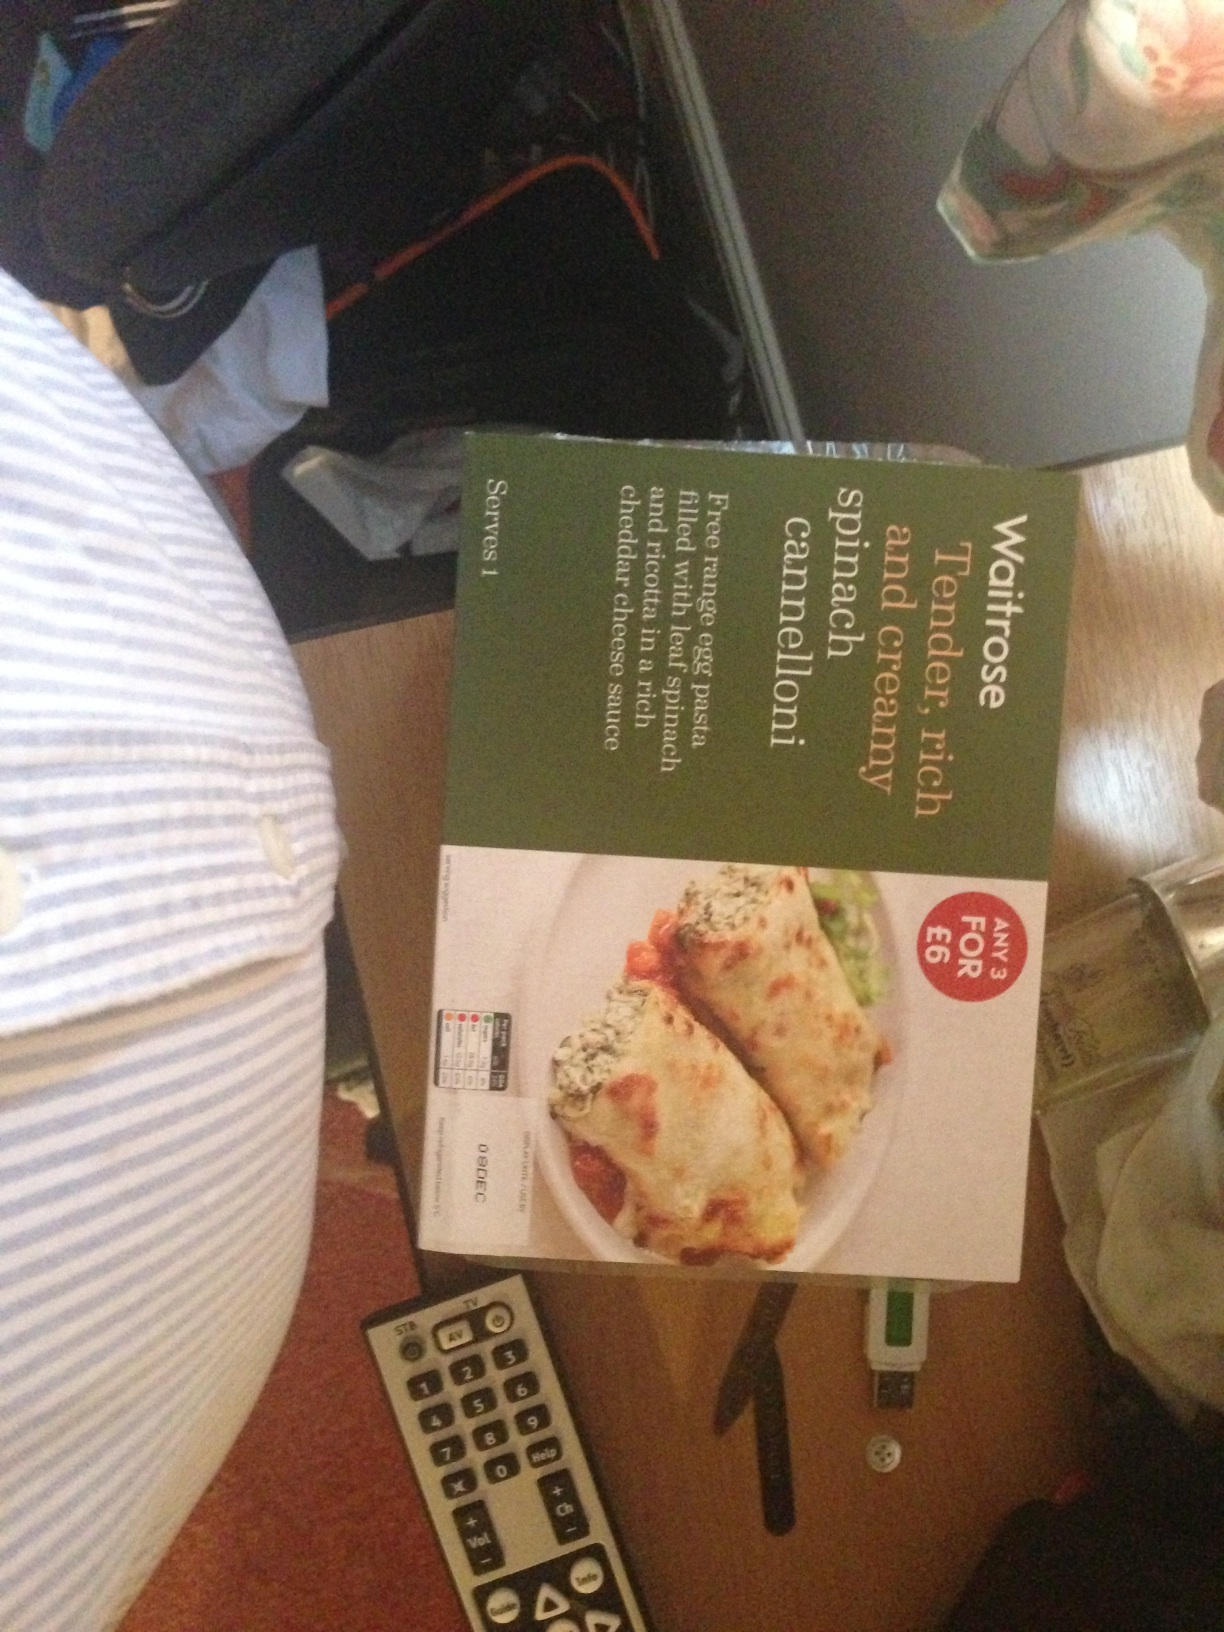What are some serving suggestions for this type of ready meal? This spinach cannelloni can be enjoyed as it is, straight from the oven or microwave. For a more balanced meal, consider serving it with a side of mixed greens or a fresh salad, adding some color and nutritional variety to your plate. A slice of garlic bread could also complement the rich flavors of the pasta and sauce. 